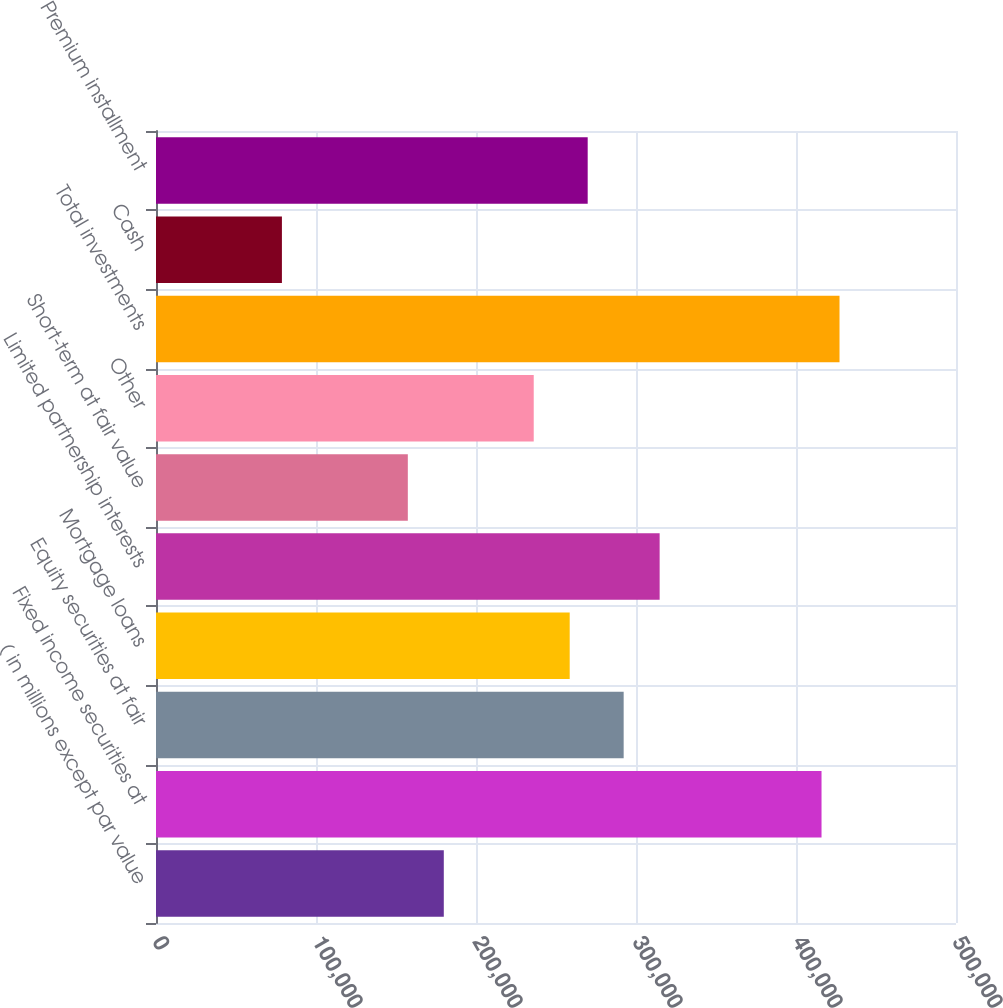Convert chart. <chart><loc_0><loc_0><loc_500><loc_500><bar_chart><fcel>( in millions except par value<fcel>Fixed income securities at<fcel>Equity securities at fair<fcel>Mortgage loans<fcel>Limited partnership interests<fcel>Short-term at fair value<fcel>Other<fcel>Total investments<fcel>Cash<fcel>Premium installment<nl><fcel>179873<fcel>415953<fcel>292292<fcel>258567<fcel>314776<fcel>157390<fcel>236083<fcel>427195<fcel>78696.3<fcel>269809<nl></chart> 